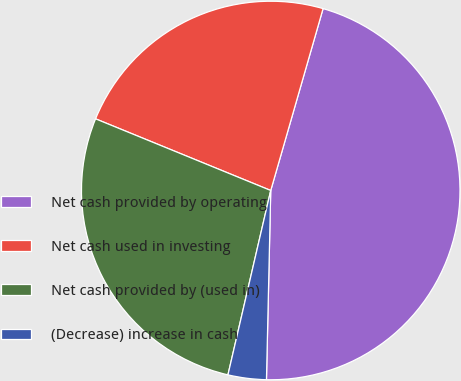Convert chart to OTSL. <chart><loc_0><loc_0><loc_500><loc_500><pie_chart><fcel>Net cash provided by operating<fcel>Net cash used in investing<fcel>Net cash provided by (used in)<fcel>(Decrease) increase in cash<nl><fcel>45.9%<fcel>23.28%<fcel>27.55%<fcel>3.27%<nl></chart> 